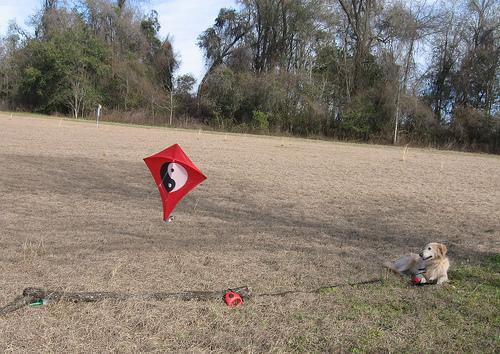Question: who is in the image?
Choices:
A. Dog.
B. Teacher.
C. Nurse.
D. Fireman.
Answer with the letter. Answer: A 